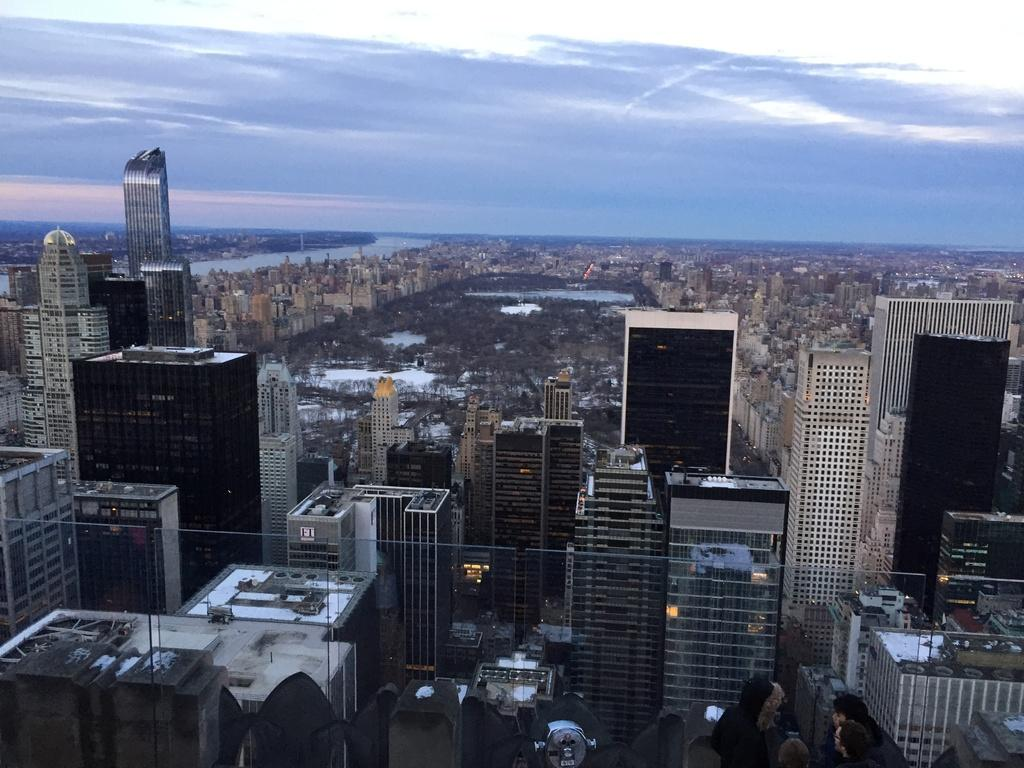What type of structures can be seen in the image? There are buildings in the image. What material is visible in the image? There is glass visible in the image. Who or what is present in the image? There are people in the image. What type of vegetation is visible in the image? There are trees in the image. What natural element is visible in the image? There is water visible in the image. What is visible at the top of the image? The sky is visible in the image. What can be seen in the sky in the image? There are clouds in the sky. What type of finger can be seen in the image? There is no finger present in the image. What type of engine is visible in the image? There is no engine present in the image. What type of voice can be heard in the image? There is no voice present in the image, as it is a still image. 